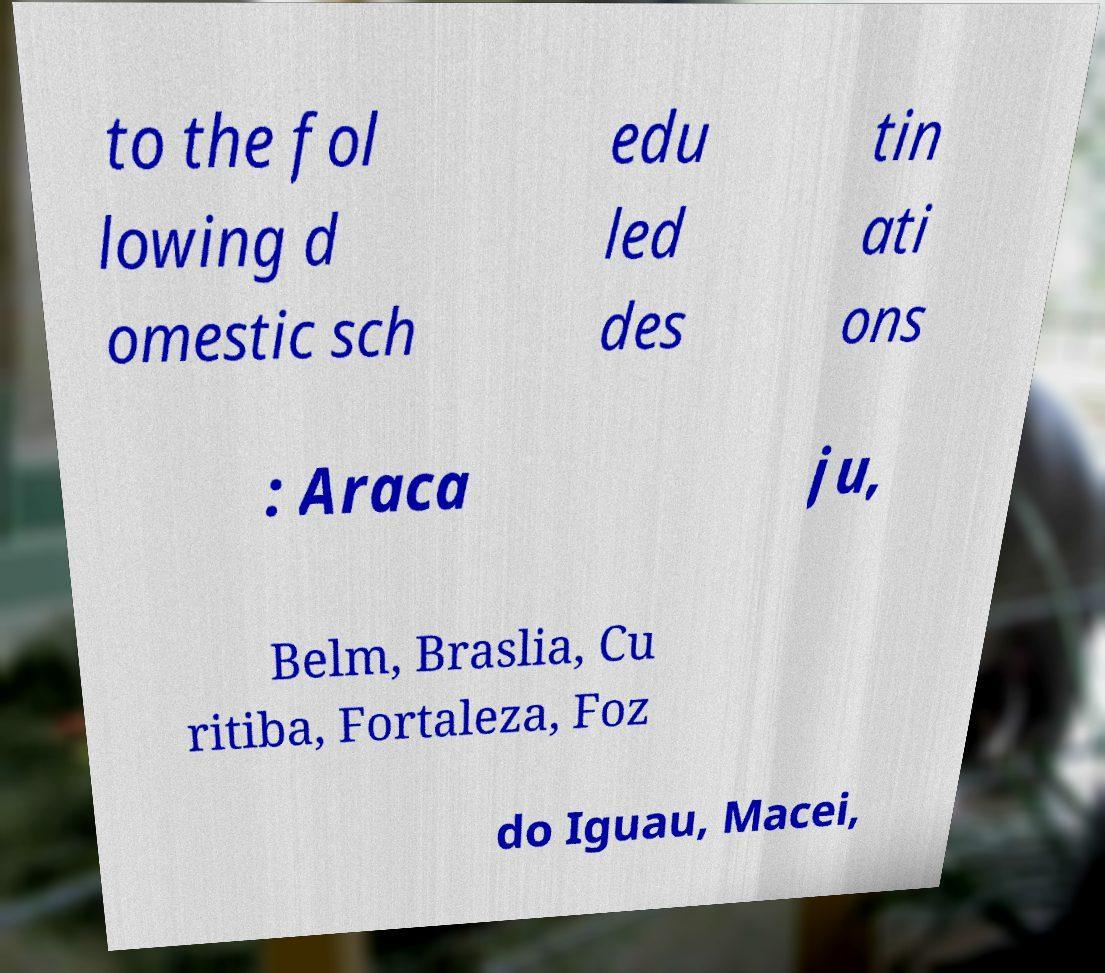Could you assist in decoding the text presented in this image and type it out clearly? to the fol lowing d omestic sch edu led des tin ati ons : Araca ju, Belm, Braslia, Cu ritiba, Fortaleza, Foz do Iguau, Macei, 